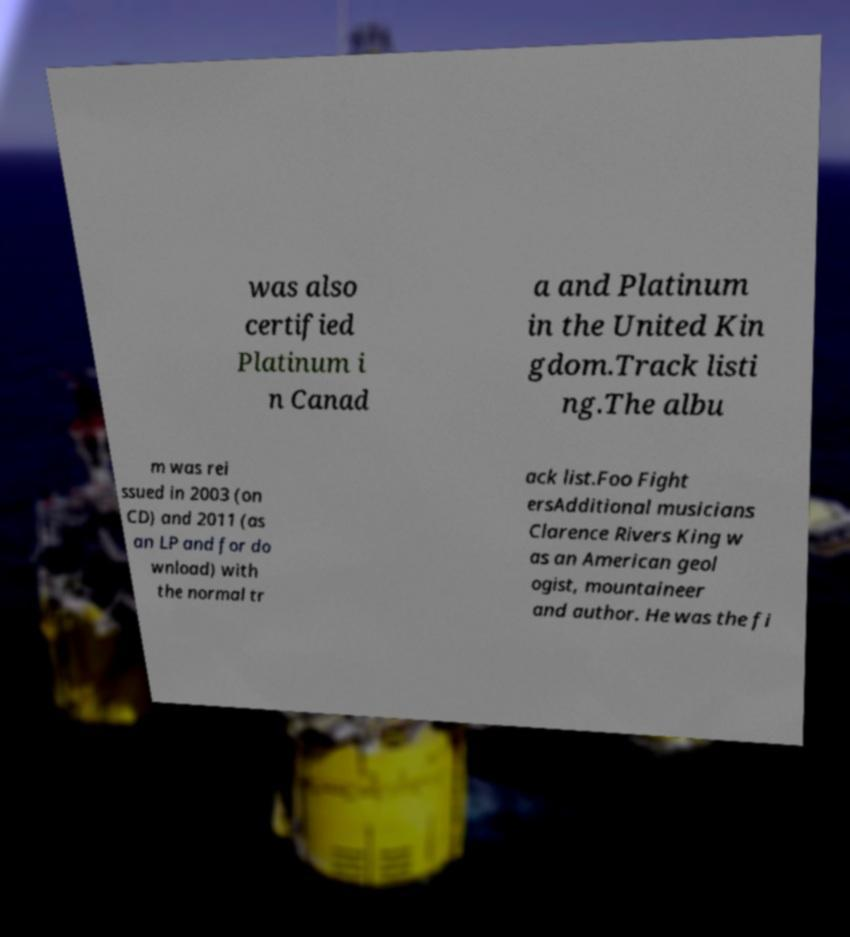I need the written content from this picture converted into text. Can you do that? was also certified Platinum i n Canad a and Platinum in the United Kin gdom.Track listi ng.The albu m was rei ssued in 2003 (on CD) and 2011 (as an LP and for do wnload) with the normal tr ack list.Foo Fight ersAdditional musicians Clarence Rivers King w as an American geol ogist, mountaineer and author. He was the fi 